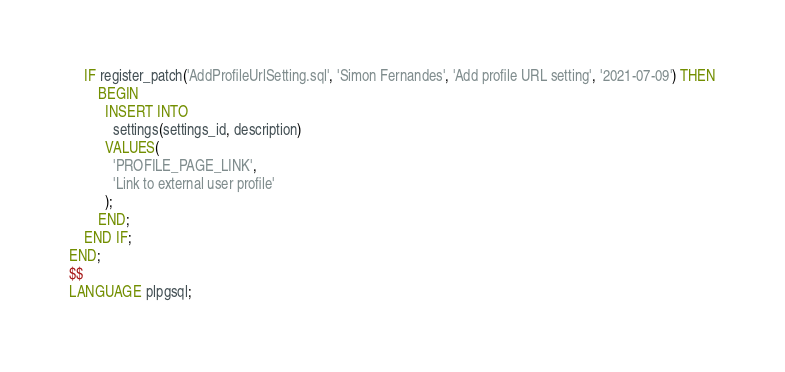Convert code to text. <code><loc_0><loc_0><loc_500><loc_500><_SQL_>	IF register_patch('AddProfileUrlSetting.sql', 'Simon Fernandes', 'Add profile URL setting', '2021-07-09') THEN
		BEGIN
		  INSERT INTO 
			settings(settings_id, description)
		  VALUES(
			'PROFILE_PAGE_LINK',
			'Link to external user profile'
		  );
		END;
	END IF;
END;
$$
LANGUAGE plpgsql;
</code> 